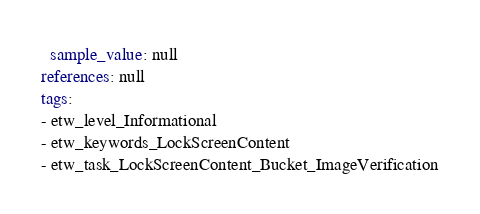<code> <loc_0><loc_0><loc_500><loc_500><_YAML_>  sample_value: null
references: null
tags:
- etw_level_Informational
- etw_keywords_LockScreenContent
- etw_task_LockScreenContent_Bucket_ImageVerification
</code> 